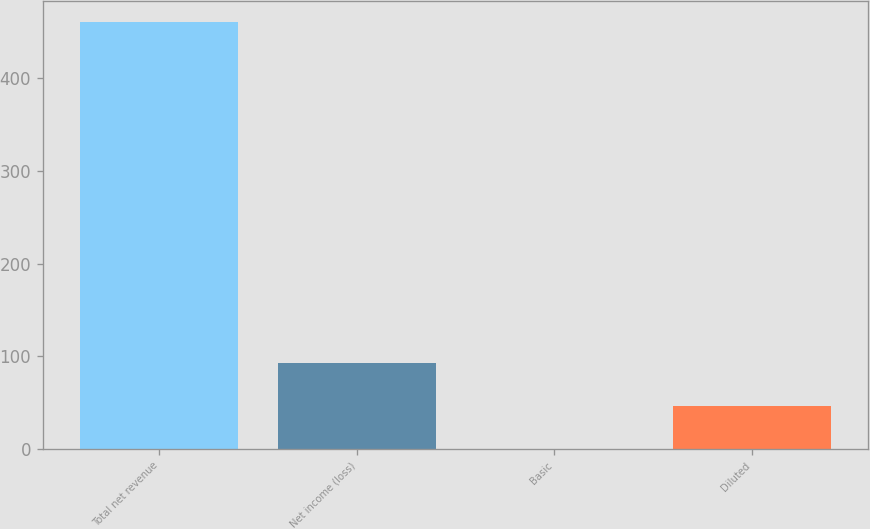Convert chart to OTSL. <chart><loc_0><loc_0><loc_500><loc_500><bar_chart><fcel>Total net revenue<fcel>Net income (loss)<fcel>Basic<fcel>Diluted<nl><fcel>461<fcel>92.32<fcel>0.14<fcel>46.23<nl></chart> 